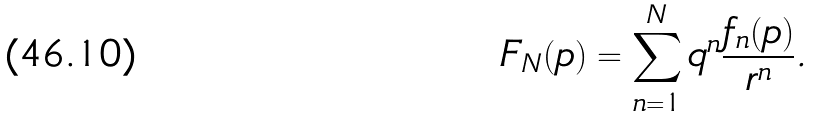<formula> <loc_0><loc_0><loc_500><loc_500>F _ { N } ( p ) = \sum _ { n = 1 } ^ { N } q ^ { n } \frac { f _ { n } ( p ) } { r ^ { n } } .</formula> 